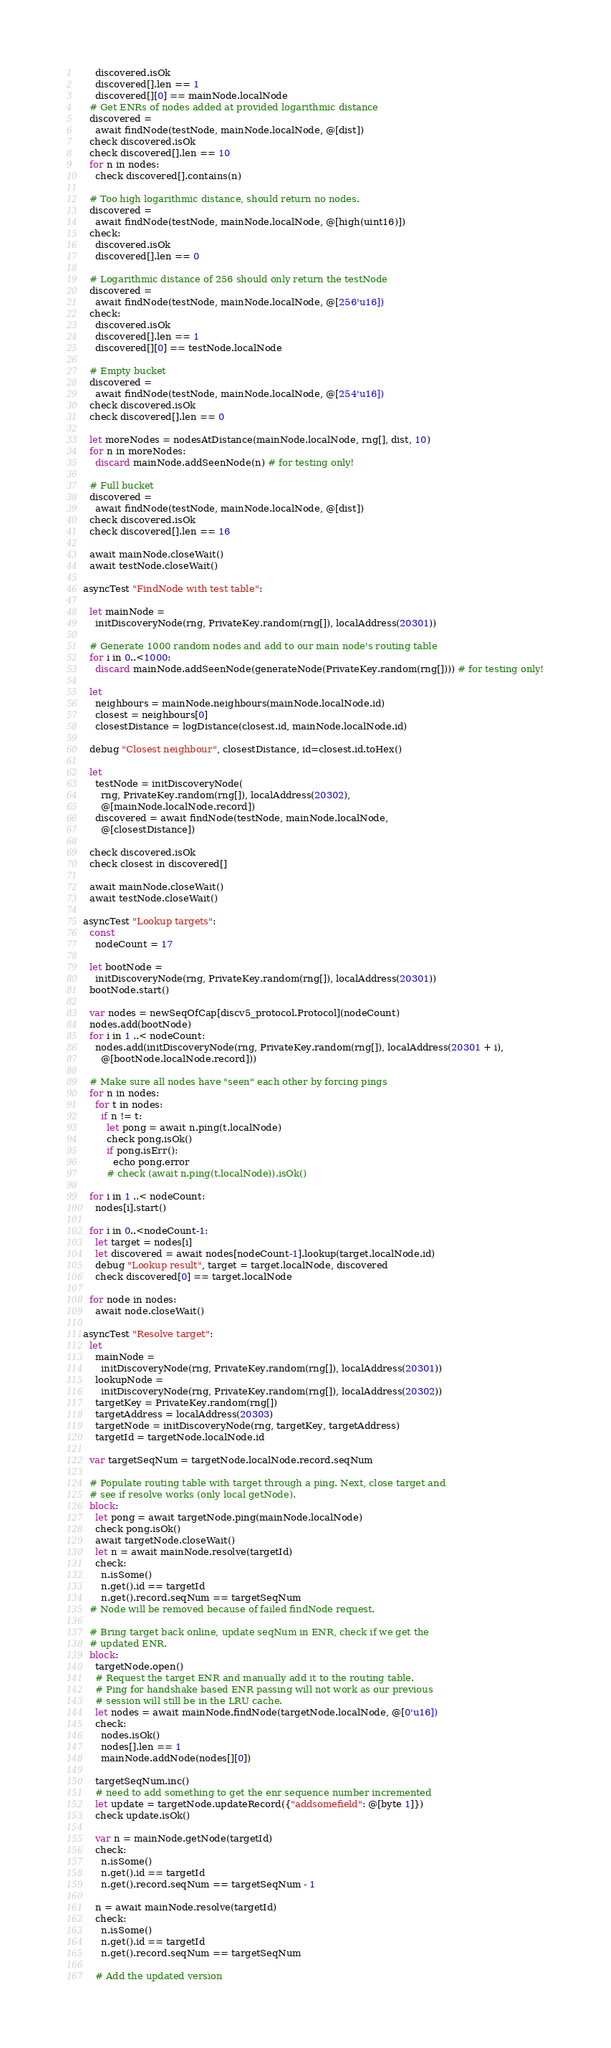Convert code to text. <code><loc_0><loc_0><loc_500><loc_500><_Nim_>      discovered.isOk
      discovered[].len == 1
      discovered[][0] == mainNode.localNode
    # Get ENRs of nodes added at provided logarithmic distance
    discovered =
      await findNode(testNode, mainNode.localNode, @[dist])
    check discovered.isOk
    check discovered[].len == 10
    for n in nodes:
      check discovered[].contains(n)

    # Too high logarithmic distance, should return no nodes.
    discovered =
      await findNode(testNode, mainNode.localNode, @[high(uint16)])
    check:
      discovered.isOk
      discovered[].len == 0

    # Logarithmic distance of 256 should only return the testNode
    discovered =
      await findNode(testNode, mainNode.localNode, @[256'u16])
    check:
      discovered.isOk
      discovered[].len == 1
      discovered[][0] == testNode.localNode

    # Empty bucket
    discovered =
      await findNode(testNode, mainNode.localNode, @[254'u16])
    check discovered.isOk
    check discovered[].len == 0

    let moreNodes = nodesAtDistance(mainNode.localNode, rng[], dist, 10)
    for n in moreNodes:
      discard mainNode.addSeenNode(n) # for testing only!

    # Full bucket
    discovered =
      await findNode(testNode, mainNode.localNode, @[dist])
    check discovered.isOk
    check discovered[].len == 16

    await mainNode.closeWait()
    await testNode.closeWait()

  asyncTest "FindNode with test table":

    let mainNode =
      initDiscoveryNode(rng, PrivateKey.random(rng[]), localAddress(20301))

    # Generate 1000 random nodes and add to our main node's routing table
    for i in 0..<1000:
      discard mainNode.addSeenNode(generateNode(PrivateKey.random(rng[]))) # for testing only!

    let
      neighbours = mainNode.neighbours(mainNode.localNode.id)
      closest = neighbours[0]
      closestDistance = logDistance(closest.id, mainNode.localNode.id)

    debug "Closest neighbour", closestDistance, id=closest.id.toHex()

    let
      testNode = initDiscoveryNode(
        rng, PrivateKey.random(rng[]), localAddress(20302),
        @[mainNode.localNode.record])
      discovered = await findNode(testNode, mainNode.localNode,
        @[closestDistance])

    check discovered.isOk
    check closest in discovered[]

    await mainNode.closeWait()
    await testNode.closeWait()

  asyncTest "Lookup targets":
    const
      nodeCount = 17

    let bootNode =
      initDiscoveryNode(rng, PrivateKey.random(rng[]), localAddress(20301))
    bootNode.start()

    var nodes = newSeqOfCap[discv5_protocol.Protocol](nodeCount)
    nodes.add(bootNode)
    for i in 1 ..< nodeCount:
      nodes.add(initDiscoveryNode(rng, PrivateKey.random(rng[]), localAddress(20301 + i),
        @[bootNode.localNode.record]))

    # Make sure all nodes have "seen" each other by forcing pings
    for n in nodes:
      for t in nodes:
        if n != t:
          let pong = await n.ping(t.localNode)
          check pong.isOk()
          if pong.isErr():
            echo pong.error
          # check (await n.ping(t.localNode)).isOk()

    for i in 1 ..< nodeCount:
      nodes[i].start()

    for i in 0..<nodeCount-1:
      let target = nodes[i]
      let discovered = await nodes[nodeCount-1].lookup(target.localNode.id)
      debug "Lookup result", target = target.localNode, discovered
      check discovered[0] == target.localNode

    for node in nodes:
      await node.closeWait()

  asyncTest "Resolve target":
    let
      mainNode =
        initDiscoveryNode(rng, PrivateKey.random(rng[]), localAddress(20301))
      lookupNode =
        initDiscoveryNode(rng, PrivateKey.random(rng[]), localAddress(20302))
      targetKey = PrivateKey.random(rng[])
      targetAddress = localAddress(20303)
      targetNode = initDiscoveryNode(rng, targetKey, targetAddress)
      targetId = targetNode.localNode.id

    var targetSeqNum = targetNode.localNode.record.seqNum

    # Populate routing table with target through a ping. Next, close target and
    # see if resolve works (only local getNode).
    block:
      let pong = await targetNode.ping(mainNode.localNode)
      check pong.isOk()
      await targetNode.closeWait()
      let n = await mainNode.resolve(targetId)
      check:
        n.isSome()
        n.get().id == targetId
        n.get().record.seqNum == targetSeqNum
    # Node will be removed because of failed findNode request.

    # Bring target back online, update seqNum in ENR, check if we get the
    # updated ENR.
    block:
      targetNode.open()
      # Request the target ENR and manually add it to the routing table.
      # Ping for handshake based ENR passing will not work as our previous
      # session will still be in the LRU cache.
      let nodes = await mainNode.findNode(targetNode.localNode, @[0'u16])
      check:
        nodes.isOk()
        nodes[].len == 1
        mainNode.addNode(nodes[][0])

      targetSeqNum.inc()
      # need to add something to get the enr sequence number incremented
      let update = targetNode.updateRecord({"addsomefield": @[byte 1]})
      check update.isOk()

      var n = mainNode.getNode(targetId)
      check:
        n.isSome()
        n.get().id == targetId
        n.get().record.seqNum == targetSeqNum - 1

      n = await mainNode.resolve(targetId)
      check:
        n.isSome()
        n.get().id == targetId
        n.get().record.seqNum == targetSeqNum

      # Add the updated version</code> 